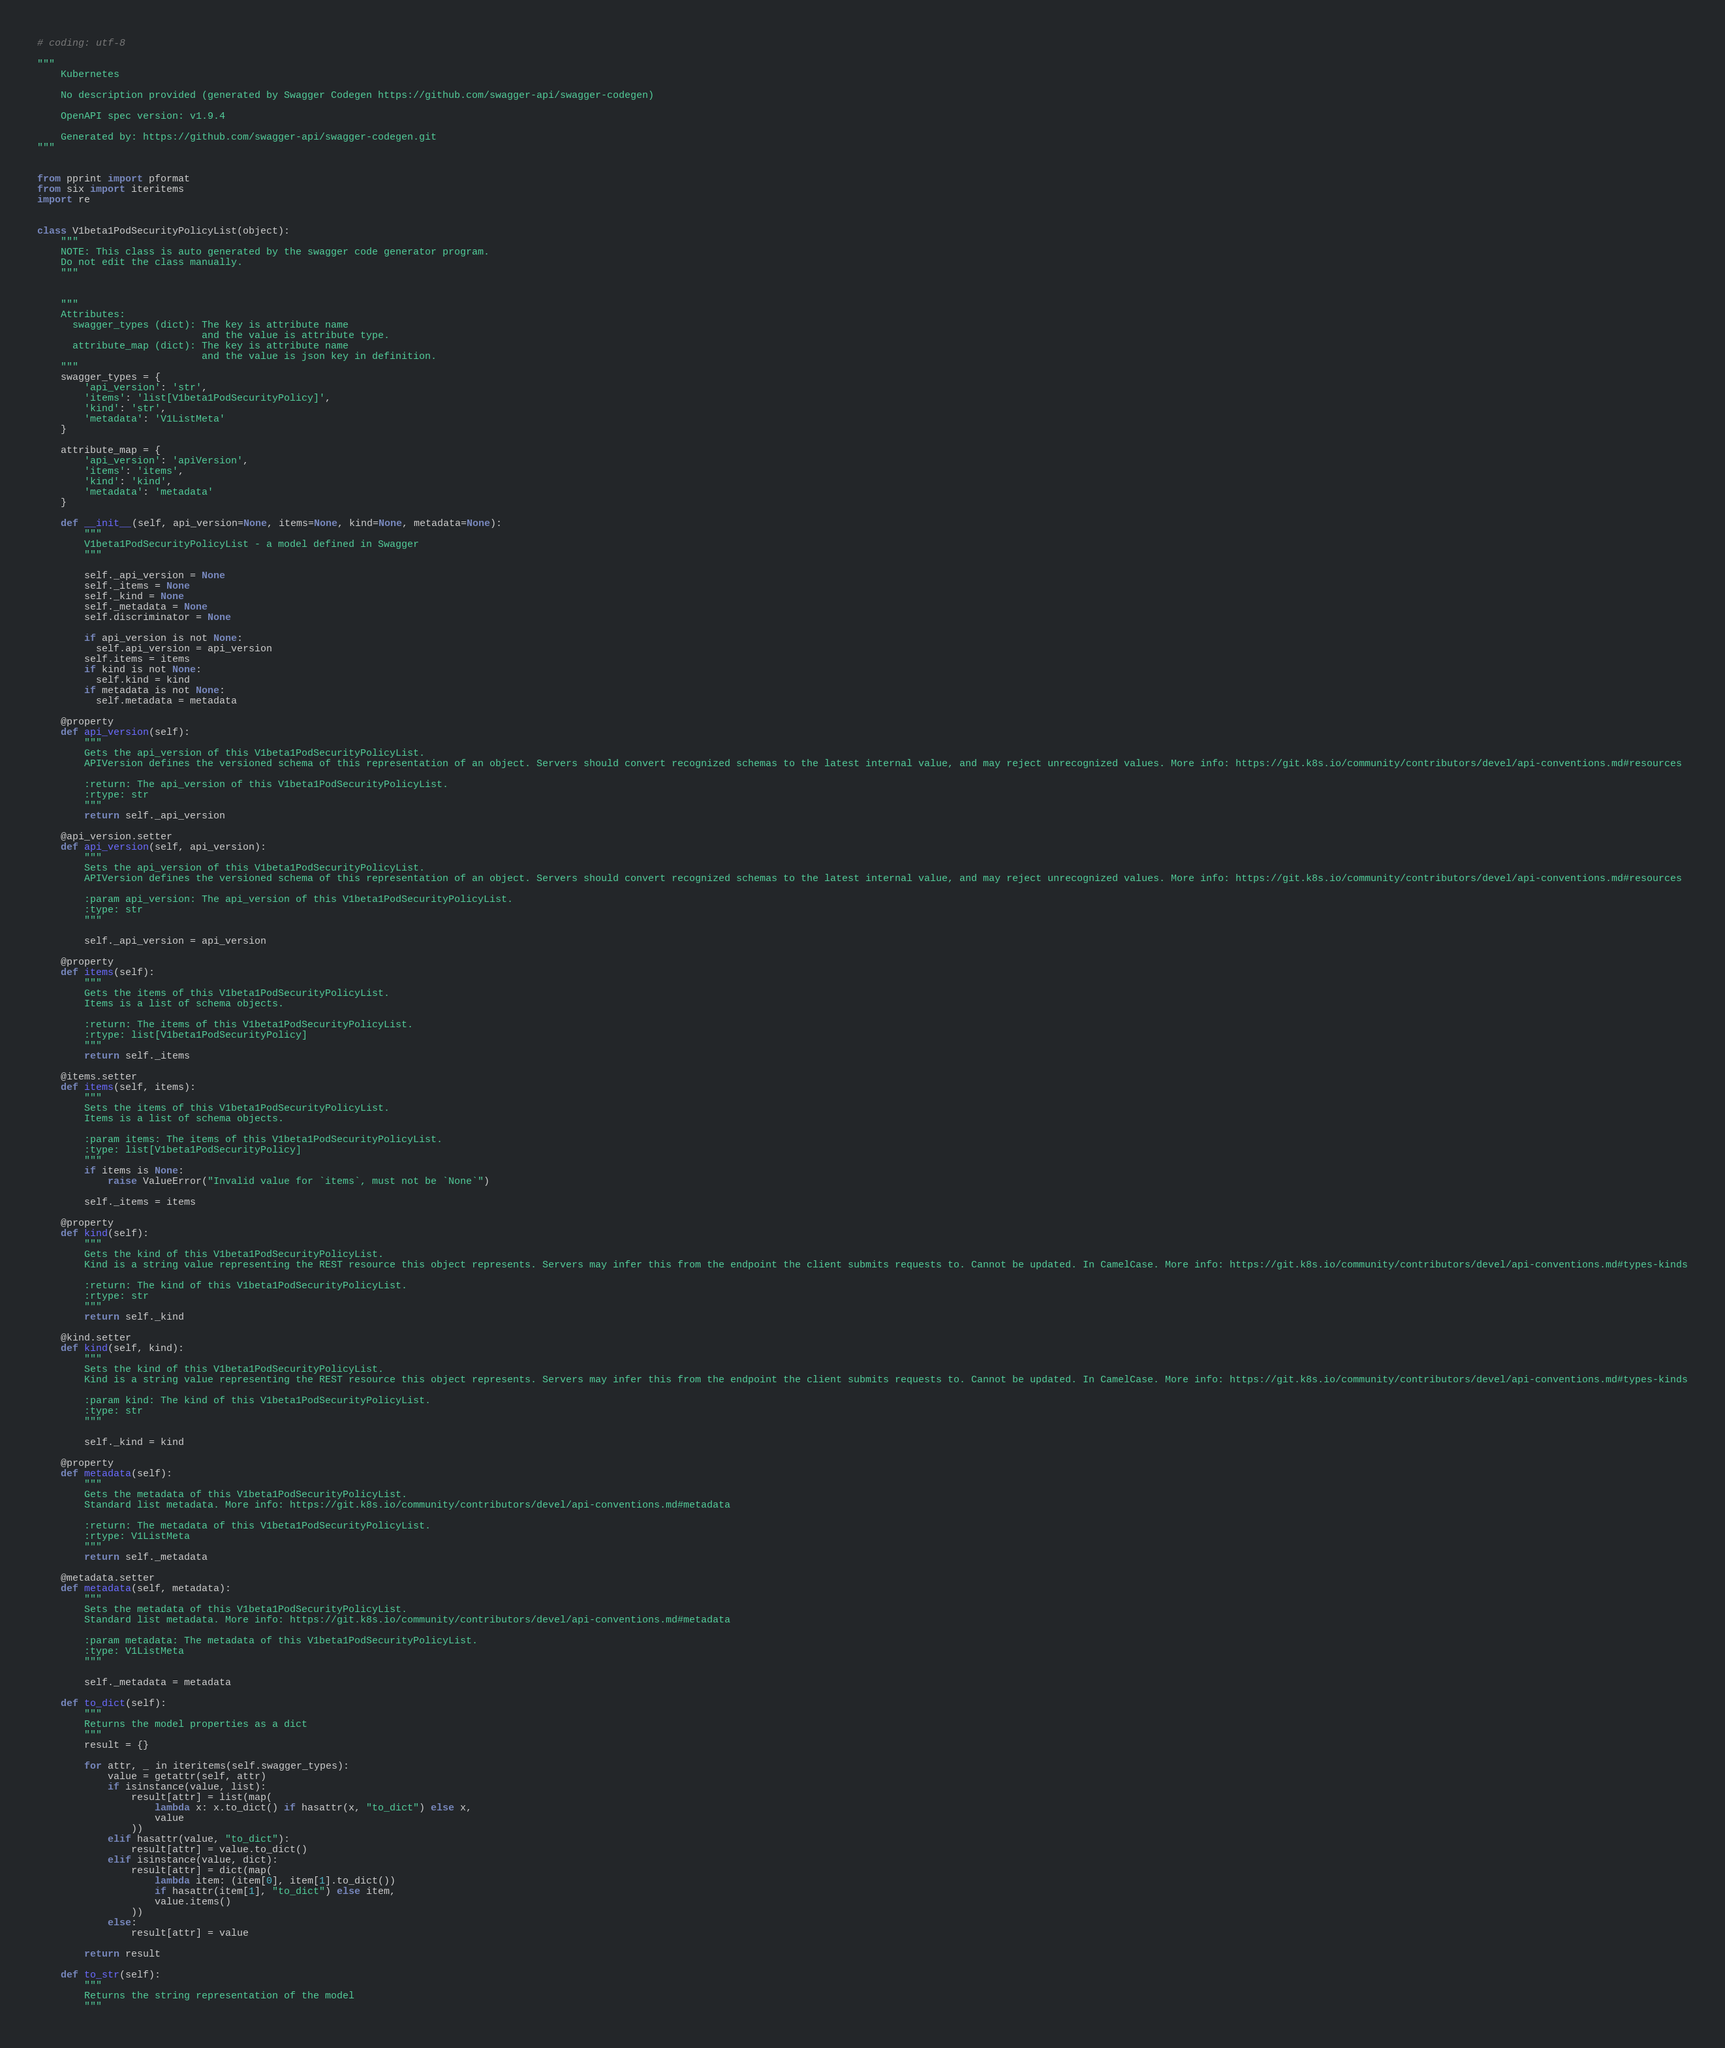Convert code to text. <code><loc_0><loc_0><loc_500><loc_500><_Python_># coding: utf-8

"""
    Kubernetes

    No description provided (generated by Swagger Codegen https://github.com/swagger-api/swagger-codegen)

    OpenAPI spec version: v1.9.4
    
    Generated by: https://github.com/swagger-api/swagger-codegen.git
"""


from pprint import pformat
from six import iteritems
import re


class V1beta1PodSecurityPolicyList(object):
    """
    NOTE: This class is auto generated by the swagger code generator program.
    Do not edit the class manually.
    """


    """
    Attributes:
      swagger_types (dict): The key is attribute name
                            and the value is attribute type.
      attribute_map (dict): The key is attribute name
                            and the value is json key in definition.
    """
    swagger_types = {
        'api_version': 'str',
        'items': 'list[V1beta1PodSecurityPolicy]',
        'kind': 'str',
        'metadata': 'V1ListMeta'
    }

    attribute_map = {
        'api_version': 'apiVersion',
        'items': 'items',
        'kind': 'kind',
        'metadata': 'metadata'
    }

    def __init__(self, api_version=None, items=None, kind=None, metadata=None):
        """
        V1beta1PodSecurityPolicyList - a model defined in Swagger
        """

        self._api_version = None
        self._items = None
        self._kind = None
        self._metadata = None
        self.discriminator = None

        if api_version is not None:
          self.api_version = api_version
        self.items = items
        if kind is not None:
          self.kind = kind
        if metadata is not None:
          self.metadata = metadata

    @property
    def api_version(self):
        """
        Gets the api_version of this V1beta1PodSecurityPolicyList.
        APIVersion defines the versioned schema of this representation of an object. Servers should convert recognized schemas to the latest internal value, and may reject unrecognized values. More info: https://git.k8s.io/community/contributors/devel/api-conventions.md#resources

        :return: The api_version of this V1beta1PodSecurityPolicyList.
        :rtype: str
        """
        return self._api_version

    @api_version.setter
    def api_version(self, api_version):
        """
        Sets the api_version of this V1beta1PodSecurityPolicyList.
        APIVersion defines the versioned schema of this representation of an object. Servers should convert recognized schemas to the latest internal value, and may reject unrecognized values. More info: https://git.k8s.io/community/contributors/devel/api-conventions.md#resources

        :param api_version: The api_version of this V1beta1PodSecurityPolicyList.
        :type: str
        """

        self._api_version = api_version

    @property
    def items(self):
        """
        Gets the items of this V1beta1PodSecurityPolicyList.
        Items is a list of schema objects.

        :return: The items of this V1beta1PodSecurityPolicyList.
        :rtype: list[V1beta1PodSecurityPolicy]
        """
        return self._items

    @items.setter
    def items(self, items):
        """
        Sets the items of this V1beta1PodSecurityPolicyList.
        Items is a list of schema objects.

        :param items: The items of this V1beta1PodSecurityPolicyList.
        :type: list[V1beta1PodSecurityPolicy]
        """
        if items is None:
            raise ValueError("Invalid value for `items`, must not be `None`")

        self._items = items

    @property
    def kind(self):
        """
        Gets the kind of this V1beta1PodSecurityPolicyList.
        Kind is a string value representing the REST resource this object represents. Servers may infer this from the endpoint the client submits requests to. Cannot be updated. In CamelCase. More info: https://git.k8s.io/community/contributors/devel/api-conventions.md#types-kinds

        :return: The kind of this V1beta1PodSecurityPolicyList.
        :rtype: str
        """
        return self._kind

    @kind.setter
    def kind(self, kind):
        """
        Sets the kind of this V1beta1PodSecurityPolicyList.
        Kind is a string value representing the REST resource this object represents. Servers may infer this from the endpoint the client submits requests to. Cannot be updated. In CamelCase. More info: https://git.k8s.io/community/contributors/devel/api-conventions.md#types-kinds

        :param kind: The kind of this V1beta1PodSecurityPolicyList.
        :type: str
        """

        self._kind = kind

    @property
    def metadata(self):
        """
        Gets the metadata of this V1beta1PodSecurityPolicyList.
        Standard list metadata. More info: https://git.k8s.io/community/contributors/devel/api-conventions.md#metadata

        :return: The metadata of this V1beta1PodSecurityPolicyList.
        :rtype: V1ListMeta
        """
        return self._metadata

    @metadata.setter
    def metadata(self, metadata):
        """
        Sets the metadata of this V1beta1PodSecurityPolicyList.
        Standard list metadata. More info: https://git.k8s.io/community/contributors/devel/api-conventions.md#metadata

        :param metadata: The metadata of this V1beta1PodSecurityPolicyList.
        :type: V1ListMeta
        """

        self._metadata = metadata

    def to_dict(self):
        """
        Returns the model properties as a dict
        """
        result = {}

        for attr, _ in iteritems(self.swagger_types):
            value = getattr(self, attr)
            if isinstance(value, list):
                result[attr] = list(map(
                    lambda x: x.to_dict() if hasattr(x, "to_dict") else x,
                    value
                ))
            elif hasattr(value, "to_dict"):
                result[attr] = value.to_dict()
            elif isinstance(value, dict):
                result[attr] = dict(map(
                    lambda item: (item[0], item[1].to_dict())
                    if hasattr(item[1], "to_dict") else item,
                    value.items()
                ))
            else:
                result[attr] = value

        return result

    def to_str(self):
        """
        Returns the string representation of the model
        """</code> 